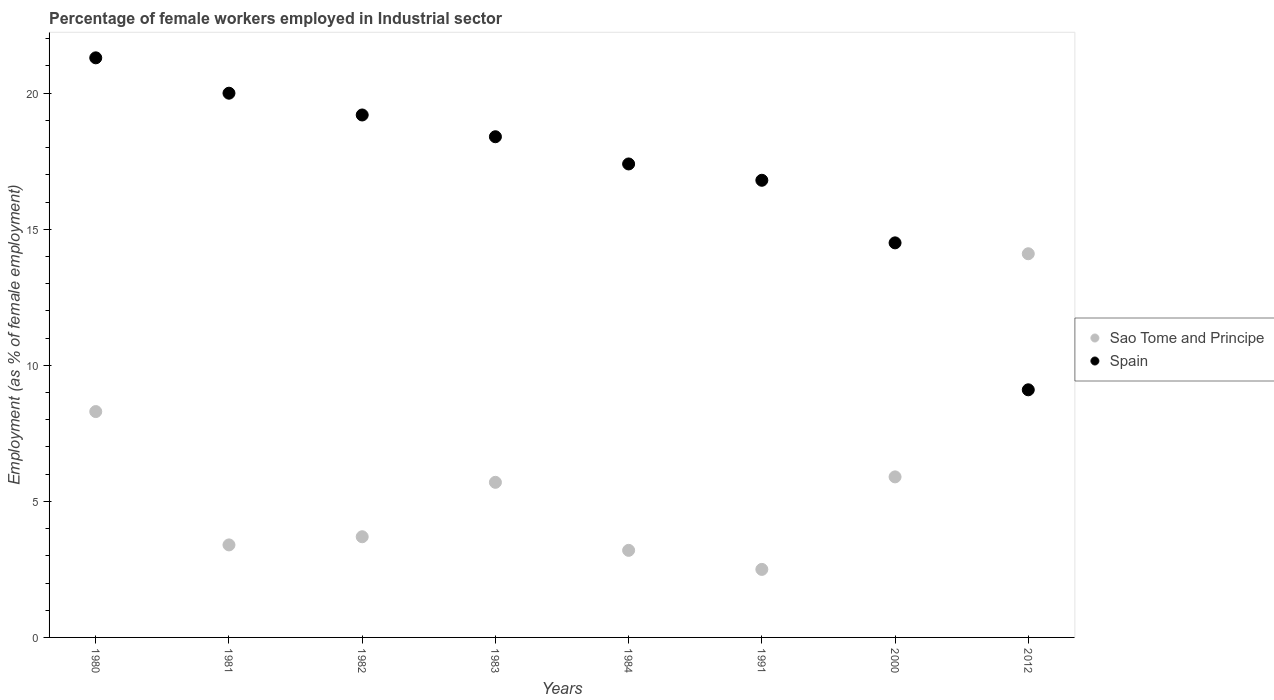Is the number of dotlines equal to the number of legend labels?
Offer a very short reply. Yes. What is the percentage of females employed in Industrial sector in Sao Tome and Principe in 1981?
Provide a succinct answer. 3.4. Across all years, what is the maximum percentage of females employed in Industrial sector in Spain?
Make the answer very short. 21.3. What is the total percentage of females employed in Industrial sector in Spain in the graph?
Make the answer very short. 136.7. What is the difference between the percentage of females employed in Industrial sector in Sao Tome and Principe in 1981 and that in 1983?
Your answer should be compact. -2.3. What is the difference between the percentage of females employed in Industrial sector in Spain in 2000 and the percentage of females employed in Industrial sector in Sao Tome and Principe in 1982?
Give a very brief answer. 10.8. What is the average percentage of females employed in Industrial sector in Sao Tome and Principe per year?
Offer a terse response. 5.85. In the year 1982, what is the difference between the percentage of females employed in Industrial sector in Sao Tome and Principe and percentage of females employed in Industrial sector in Spain?
Your answer should be compact. -15.5. What is the ratio of the percentage of females employed in Industrial sector in Spain in 1980 to that in 2012?
Offer a terse response. 2.34. Is the difference between the percentage of females employed in Industrial sector in Sao Tome and Principe in 1980 and 1981 greater than the difference between the percentage of females employed in Industrial sector in Spain in 1980 and 1981?
Provide a succinct answer. Yes. What is the difference between the highest and the second highest percentage of females employed in Industrial sector in Spain?
Offer a very short reply. 1.3. What is the difference between the highest and the lowest percentage of females employed in Industrial sector in Sao Tome and Principe?
Provide a succinct answer. 11.6. In how many years, is the percentage of females employed in Industrial sector in Sao Tome and Principe greater than the average percentage of females employed in Industrial sector in Sao Tome and Principe taken over all years?
Your response must be concise. 3. Is the percentage of females employed in Industrial sector in Sao Tome and Principe strictly greater than the percentage of females employed in Industrial sector in Spain over the years?
Offer a terse response. No. What is the difference between two consecutive major ticks on the Y-axis?
Provide a succinct answer. 5. Does the graph contain grids?
Offer a very short reply. No. What is the title of the graph?
Provide a succinct answer. Percentage of female workers employed in Industrial sector. Does "Rwanda" appear as one of the legend labels in the graph?
Make the answer very short. No. What is the label or title of the Y-axis?
Make the answer very short. Employment (as % of female employment). What is the Employment (as % of female employment) of Sao Tome and Principe in 1980?
Keep it short and to the point. 8.3. What is the Employment (as % of female employment) of Spain in 1980?
Give a very brief answer. 21.3. What is the Employment (as % of female employment) of Sao Tome and Principe in 1981?
Your response must be concise. 3.4. What is the Employment (as % of female employment) in Spain in 1981?
Ensure brevity in your answer.  20. What is the Employment (as % of female employment) of Sao Tome and Principe in 1982?
Provide a short and direct response. 3.7. What is the Employment (as % of female employment) of Spain in 1982?
Your answer should be very brief. 19.2. What is the Employment (as % of female employment) in Sao Tome and Principe in 1983?
Provide a succinct answer. 5.7. What is the Employment (as % of female employment) of Spain in 1983?
Your answer should be very brief. 18.4. What is the Employment (as % of female employment) in Sao Tome and Principe in 1984?
Your response must be concise. 3.2. What is the Employment (as % of female employment) of Spain in 1984?
Offer a terse response. 17.4. What is the Employment (as % of female employment) of Sao Tome and Principe in 1991?
Make the answer very short. 2.5. What is the Employment (as % of female employment) of Spain in 1991?
Keep it short and to the point. 16.8. What is the Employment (as % of female employment) of Sao Tome and Principe in 2000?
Keep it short and to the point. 5.9. What is the Employment (as % of female employment) of Sao Tome and Principe in 2012?
Offer a terse response. 14.1. What is the Employment (as % of female employment) of Spain in 2012?
Your answer should be very brief. 9.1. Across all years, what is the maximum Employment (as % of female employment) of Sao Tome and Principe?
Offer a very short reply. 14.1. Across all years, what is the maximum Employment (as % of female employment) in Spain?
Your answer should be compact. 21.3. Across all years, what is the minimum Employment (as % of female employment) of Sao Tome and Principe?
Offer a very short reply. 2.5. Across all years, what is the minimum Employment (as % of female employment) of Spain?
Offer a terse response. 9.1. What is the total Employment (as % of female employment) of Sao Tome and Principe in the graph?
Your response must be concise. 46.8. What is the total Employment (as % of female employment) in Spain in the graph?
Make the answer very short. 136.7. What is the difference between the Employment (as % of female employment) in Spain in 1980 and that in 1982?
Keep it short and to the point. 2.1. What is the difference between the Employment (as % of female employment) in Sao Tome and Principe in 1980 and that in 1983?
Make the answer very short. 2.6. What is the difference between the Employment (as % of female employment) of Sao Tome and Principe in 1980 and that in 1984?
Provide a short and direct response. 5.1. What is the difference between the Employment (as % of female employment) of Spain in 1980 and that in 1984?
Offer a very short reply. 3.9. What is the difference between the Employment (as % of female employment) of Sao Tome and Principe in 1980 and that in 2000?
Keep it short and to the point. 2.4. What is the difference between the Employment (as % of female employment) of Spain in 1980 and that in 2012?
Ensure brevity in your answer.  12.2. What is the difference between the Employment (as % of female employment) in Spain in 1981 and that in 1983?
Offer a very short reply. 1.6. What is the difference between the Employment (as % of female employment) of Sao Tome and Principe in 1981 and that in 1984?
Provide a short and direct response. 0.2. What is the difference between the Employment (as % of female employment) in Spain in 1981 and that in 1984?
Provide a short and direct response. 2.6. What is the difference between the Employment (as % of female employment) in Sao Tome and Principe in 1981 and that in 2000?
Give a very brief answer. -2.5. What is the difference between the Employment (as % of female employment) in Sao Tome and Principe in 1982 and that in 1983?
Provide a short and direct response. -2. What is the difference between the Employment (as % of female employment) in Spain in 1982 and that in 1984?
Offer a terse response. 1.8. What is the difference between the Employment (as % of female employment) of Spain in 1982 and that in 1991?
Make the answer very short. 2.4. What is the difference between the Employment (as % of female employment) of Sao Tome and Principe in 1982 and that in 2000?
Offer a very short reply. -2.2. What is the difference between the Employment (as % of female employment) of Sao Tome and Principe in 1983 and that in 1984?
Keep it short and to the point. 2.5. What is the difference between the Employment (as % of female employment) of Spain in 1983 and that in 1984?
Offer a very short reply. 1. What is the difference between the Employment (as % of female employment) in Sao Tome and Principe in 1983 and that in 1991?
Keep it short and to the point. 3.2. What is the difference between the Employment (as % of female employment) of Spain in 1983 and that in 2000?
Keep it short and to the point. 3.9. What is the difference between the Employment (as % of female employment) in Spain in 1983 and that in 2012?
Provide a short and direct response. 9.3. What is the difference between the Employment (as % of female employment) of Sao Tome and Principe in 1984 and that in 1991?
Keep it short and to the point. 0.7. What is the difference between the Employment (as % of female employment) in Spain in 1984 and that in 1991?
Offer a very short reply. 0.6. What is the difference between the Employment (as % of female employment) of Sao Tome and Principe in 1984 and that in 2000?
Make the answer very short. -2.7. What is the difference between the Employment (as % of female employment) of Spain in 1984 and that in 2000?
Make the answer very short. 2.9. What is the difference between the Employment (as % of female employment) of Sao Tome and Principe in 1984 and that in 2012?
Provide a succinct answer. -10.9. What is the difference between the Employment (as % of female employment) in Spain in 1984 and that in 2012?
Your response must be concise. 8.3. What is the difference between the Employment (as % of female employment) of Sao Tome and Principe in 1991 and that in 2012?
Provide a short and direct response. -11.6. What is the difference between the Employment (as % of female employment) in Sao Tome and Principe in 2000 and that in 2012?
Provide a succinct answer. -8.2. What is the difference between the Employment (as % of female employment) of Spain in 2000 and that in 2012?
Your response must be concise. 5.4. What is the difference between the Employment (as % of female employment) of Sao Tome and Principe in 1980 and the Employment (as % of female employment) of Spain in 1982?
Offer a terse response. -10.9. What is the difference between the Employment (as % of female employment) of Sao Tome and Principe in 1980 and the Employment (as % of female employment) of Spain in 1984?
Provide a succinct answer. -9.1. What is the difference between the Employment (as % of female employment) of Sao Tome and Principe in 1980 and the Employment (as % of female employment) of Spain in 1991?
Provide a succinct answer. -8.5. What is the difference between the Employment (as % of female employment) of Sao Tome and Principe in 1980 and the Employment (as % of female employment) of Spain in 2000?
Ensure brevity in your answer.  -6.2. What is the difference between the Employment (as % of female employment) of Sao Tome and Principe in 1981 and the Employment (as % of female employment) of Spain in 1982?
Make the answer very short. -15.8. What is the difference between the Employment (as % of female employment) in Sao Tome and Principe in 1981 and the Employment (as % of female employment) in Spain in 2000?
Make the answer very short. -11.1. What is the difference between the Employment (as % of female employment) of Sao Tome and Principe in 1981 and the Employment (as % of female employment) of Spain in 2012?
Give a very brief answer. -5.7. What is the difference between the Employment (as % of female employment) of Sao Tome and Principe in 1982 and the Employment (as % of female employment) of Spain in 1983?
Your answer should be compact. -14.7. What is the difference between the Employment (as % of female employment) in Sao Tome and Principe in 1982 and the Employment (as % of female employment) in Spain in 1984?
Offer a very short reply. -13.7. What is the difference between the Employment (as % of female employment) in Sao Tome and Principe in 1982 and the Employment (as % of female employment) in Spain in 1991?
Make the answer very short. -13.1. What is the difference between the Employment (as % of female employment) of Sao Tome and Principe in 1982 and the Employment (as % of female employment) of Spain in 2000?
Your answer should be very brief. -10.8. What is the difference between the Employment (as % of female employment) of Sao Tome and Principe in 1983 and the Employment (as % of female employment) of Spain in 1984?
Give a very brief answer. -11.7. What is the difference between the Employment (as % of female employment) of Sao Tome and Principe in 1983 and the Employment (as % of female employment) of Spain in 1991?
Your answer should be compact. -11.1. What is the difference between the Employment (as % of female employment) of Sao Tome and Principe in 1984 and the Employment (as % of female employment) of Spain in 1991?
Your response must be concise. -13.6. What is the difference between the Employment (as % of female employment) of Sao Tome and Principe in 1984 and the Employment (as % of female employment) of Spain in 2012?
Offer a very short reply. -5.9. What is the difference between the Employment (as % of female employment) of Sao Tome and Principe in 1991 and the Employment (as % of female employment) of Spain in 2012?
Keep it short and to the point. -6.6. What is the difference between the Employment (as % of female employment) of Sao Tome and Principe in 2000 and the Employment (as % of female employment) of Spain in 2012?
Make the answer very short. -3.2. What is the average Employment (as % of female employment) in Sao Tome and Principe per year?
Your answer should be very brief. 5.85. What is the average Employment (as % of female employment) of Spain per year?
Provide a succinct answer. 17.09. In the year 1981, what is the difference between the Employment (as % of female employment) in Sao Tome and Principe and Employment (as % of female employment) in Spain?
Provide a succinct answer. -16.6. In the year 1982, what is the difference between the Employment (as % of female employment) of Sao Tome and Principe and Employment (as % of female employment) of Spain?
Provide a short and direct response. -15.5. In the year 1983, what is the difference between the Employment (as % of female employment) in Sao Tome and Principe and Employment (as % of female employment) in Spain?
Provide a succinct answer. -12.7. In the year 1991, what is the difference between the Employment (as % of female employment) of Sao Tome and Principe and Employment (as % of female employment) of Spain?
Provide a succinct answer. -14.3. What is the ratio of the Employment (as % of female employment) in Sao Tome and Principe in 1980 to that in 1981?
Your answer should be compact. 2.44. What is the ratio of the Employment (as % of female employment) of Spain in 1980 to that in 1981?
Give a very brief answer. 1.06. What is the ratio of the Employment (as % of female employment) of Sao Tome and Principe in 1980 to that in 1982?
Your answer should be compact. 2.24. What is the ratio of the Employment (as % of female employment) of Spain in 1980 to that in 1982?
Ensure brevity in your answer.  1.11. What is the ratio of the Employment (as % of female employment) of Sao Tome and Principe in 1980 to that in 1983?
Your answer should be compact. 1.46. What is the ratio of the Employment (as % of female employment) in Spain in 1980 to that in 1983?
Ensure brevity in your answer.  1.16. What is the ratio of the Employment (as % of female employment) of Sao Tome and Principe in 1980 to that in 1984?
Provide a short and direct response. 2.59. What is the ratio of the Employment (as % of female employment) of Spain in 1980 to that in 1984?
Provide a succinct answer. 1.22. What is the ratio of the Employment (as % of female employment) of Sao Tome and Principe in 1980 to that in 1991?
Provide a short and direct response. 3.32. What is the ratio of the Employment (as % of female employment) in Spain in 1980 to that in 1991?
Offer a very short reply. 1.27. What is the ratio of the Employment (as % of female employment) of Sao Tome and Principe in 1980 to that in 2000?
Your answer should be very brief. 1.41. What is the ratio of the Employment (as % of female employment) of Spain in 1980 to that in 2000?
Keep it short and to the point. 1.47. What is the ratio of the Employment (as % of female employment) in Sao Tome and Principe in 1980 to that in 2012?
Give a very brief answer. 0.59. What is the ratio of the Employment (as % of female employment) of Spain in 1980 to that in 2012?
Your answer should be compact. 2.34. What is the ratio of the Employment (as % of female employment) of Sao Tome and Principe in 1981 to that in 1982?
Keep it short and to the point. 0.92. What is the ratio of the Employment (as % of female employment) of Spain in 1981 to that in 1982?
Provide a succinct answer. 1.04. What is the ratio of the Employment (as % of female employment) of Sao Tome and Principe in 1981 to that in 1983?
Your response must be concise. 0.6. What is the ratio of the Employment (as % of female employment) of Spain in 1981 to that in 1983?
Offer a terse response. 1.09. What is the ratio of the Employment (as % of female employment) in Spain in 1981 to that in 1984?
Offer a very short reply. 1.15. What is the ratio of the Employment (as % of female employment) of Sao Tome and Principe in 1981 to that in 1991?
Ensure brevity in your answer.  1.36. What is the ratio of the Employment (as % of female employment) of Spain in 1981 to that in 1991?
Your answer should be compact. 1.19. What is the ratio of the Employment (as % of female employment) of Sao Tome and Principe in 1981 to that in 2000?
Make the answer very short. 0.58. What is the ratio of the Employment (as % of female employment) in Spain in 1981 to that in 2000?
Give a very brief answer. 1.38. What is the ratio of the Employment (as % of female employment) in Sao Tome and Principe in 1981 to that in 2012?
Make the answer very short. 0.24. What is the ratio of the Employment (as % of female employment) of Spain in 1981 to that in 2012?
Offer a very short reply. 2.2. What is the ratio of the Employment (as % of female employment) of Sao Tome and Principe in 1982 to that in 1983?
Provide a short and direct response. 0.65. What is the ratio of the Employment (as % of female employment) in Spain in 1982 to that in 1983?
Your response must be concise. 1.04. What is the ratio of the Employment (as % of female employment) in Sao Tome and Principe in 1982 to that in 1984?
Give a very brief answer. 1.16. What is the ratio of the Employment (as % of female employment) in Spain in 1982 to that in 1984?
Give a very brief answer. 1.1. What is the ratio of the Employment (as % of female employment) of Sao Tome and Principe in 1982 to that in 1991?
Give a very brief answer. 1.48. What is the ratio of the Employment (as % of female employment) of Sao Tome and Principe in 1982 to that in 2000?
Give a very brief answer. 0.63. What is the ratio of the Employment (as % of female employment) in Spain in 1982 to that in 2000?
Offer a very short reply. 1.32. What is the ratio of the Employment (as % of female employment) of Sao Tome and Principe in 1982 to that in 2012?
Give a very brief answer. 0.26. What is the ratio of the Employment (as % of female employment) of Spain in 1982 to that in 2012?
Give a very brief answer. 2.11. What is the ratio of the Employment (as % of female employment) of Sao Tome and Principe in 1983 to that in 1984?
Your response must be concise. 1.78. What is the ratio of the Employment (as % of female employment) in Spain in 1983 to that in 1984?
Your response must be concise. 1.06. What is the ratio of the Employment (as % of female employment) of Sao Tome and Principe in 1983 to that in 1991?
Your answer should be compact. 2.28. What is the ratio of the Employment (as % of female employment) of Spain in 1983 to that in 1991?
Keep it short and to the point. 1.1. What is the ratio of the Employment (as % of female employment) of Sao Tome and Principe in 1983 to that in 2000?
Keep it short and to the point. 0.97. What is the ratio of the Employment (as % of female employment) in Spain in 1983 to that in 2000?
Keep it short and to the point. 1.27. What is the ratio of the Employment (as % of female employment) of Sao Tome and Principe in 1983 to that in 2012?
Your answer should be compact. 0.4. What is the ratio of the Employment (as % of female employment) in Spain in 1983 to that in 2012?
Offer a very short reply. 2.02. What is the ratio of the Employment (as % of female employment) in Sao Tome and Principe in 1984 to that in 1991?
Keep it short and to the point. 1.28. What is the ratio of the Employment (as % of female employment) of Spain in 1984 to that in 1991?
Your answer should be very brief. 1.04. What is the ratio of the Employment (as % of female employment) of Sao Tome and Principe in 1984 to that in 2000?
Your response must be concise. 0.54. What is the ratio of the Employment (as % of female employment) of Sao Tome and Principe in 1984 to that in 2012?
Offer a very short reply. 0.23. What is the ratio of the Employment (as % of female employment) in Spain in 1984 to that in 2012?
Provide a short and direct response. 1.91. What is the ratio of the Employment (as % of female employment) in Sao Tome and Principe in 1991 to that in 2000?
Your answer should be compact. 0.42. What is the ratio of the Employment (as % of female employment) in Spain in 1991 to that in 2000?
Offer a terse response. 1.16. What is the ratio of the Employment (as % of female employment) in Sao Tome and Principe in 1991 to that in 2012?
Provide a succinct answer. 0.18. What is the ratio of the Employment (as % of female employment) in Spain in 1991 to that in 2012?
Your answer should be very brief. 1.85. What is the ratio of the Employment (as % of female employment) in Sao Tome and Principe in 2000 to that in 2012?
Make the answer very short. 0.42. What is the ratio of the Employment (as % of female employment) in Spain in 2000 to that in 2012?
Keep it short and to the point. 1.59. What is the difference between the highest and the second highest Employment (as % of female employment) in Spain?
Your response must be concise. 1.3. What is the difference between the highest and the lowest Employment (as % of female employment) of Sao Tome and Principe?
Offer a very short reply. 11.6. 